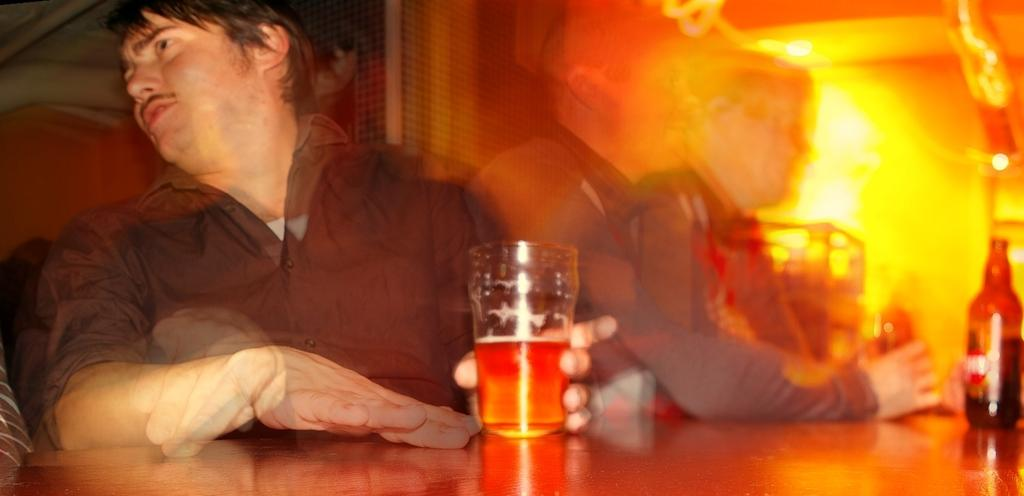What are the persons in the image doing? The persons in the image are sitting on chairs. What are the persons holding in their hands? The persons are holding glasses. What can be seen on the table in the image? There is a glass and bottles on the table. What type of animal is sitting on the chair next to the person holding a glass? There is no animal present in the image; only persons sitting on chairs and holding glasses are visible. 